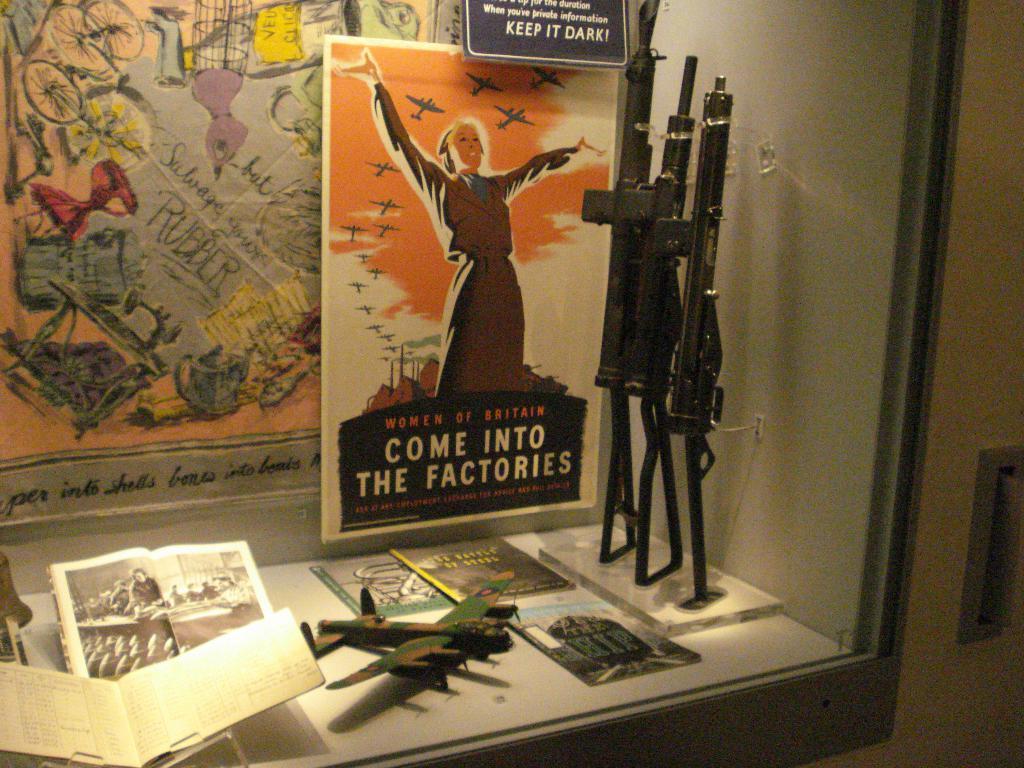What brightness does the sign tell you to keep it?
Make the answer very short. Dark. 